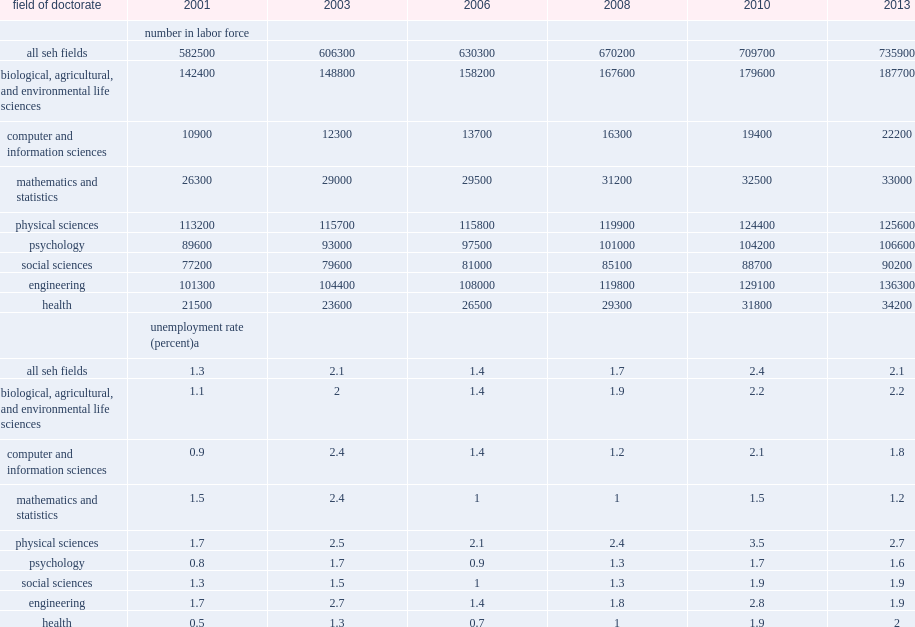How many seh doctoral degree holders in the labor force in 2013? 735900.0. Of the approximately 735,900 seh doctoral degree holders in the labor force in 2013,how many percent had earned a doctorate in the biological, agricultural, or environmental life sciences? 0.255062. Of the approximately 735,900 seh doctoral degree holders in the labor force in 2013, how many percent had doctorates in engineering? 0.185215. Of the approximately 735,900 seh doctoral degree holders in the labor force in 2013, how many percent in physical sciences? 0.170675. Of the approximately 735,900 seh doctoral degree holders in the labor force in 2013, how many percent in psychology? 0.144857. Of the approximately 735,900 seh doctoral degree holders in the labor force in 2013, how many percent in social sciences? 0.122571. Of the approximately 735,900 seh doctoral degree holders in the labor force in 2013, how many percent in health? 0.046474. Of the approximately 735,900 seh doctoral degree holders in the labor force in 2013, how many percent in mathematics and statistics? 0.044843. Of the approximately 735,900 seh doctoral degree holders in the labor force in 2013, how many percent in computer and information sciences? 0.030167. 